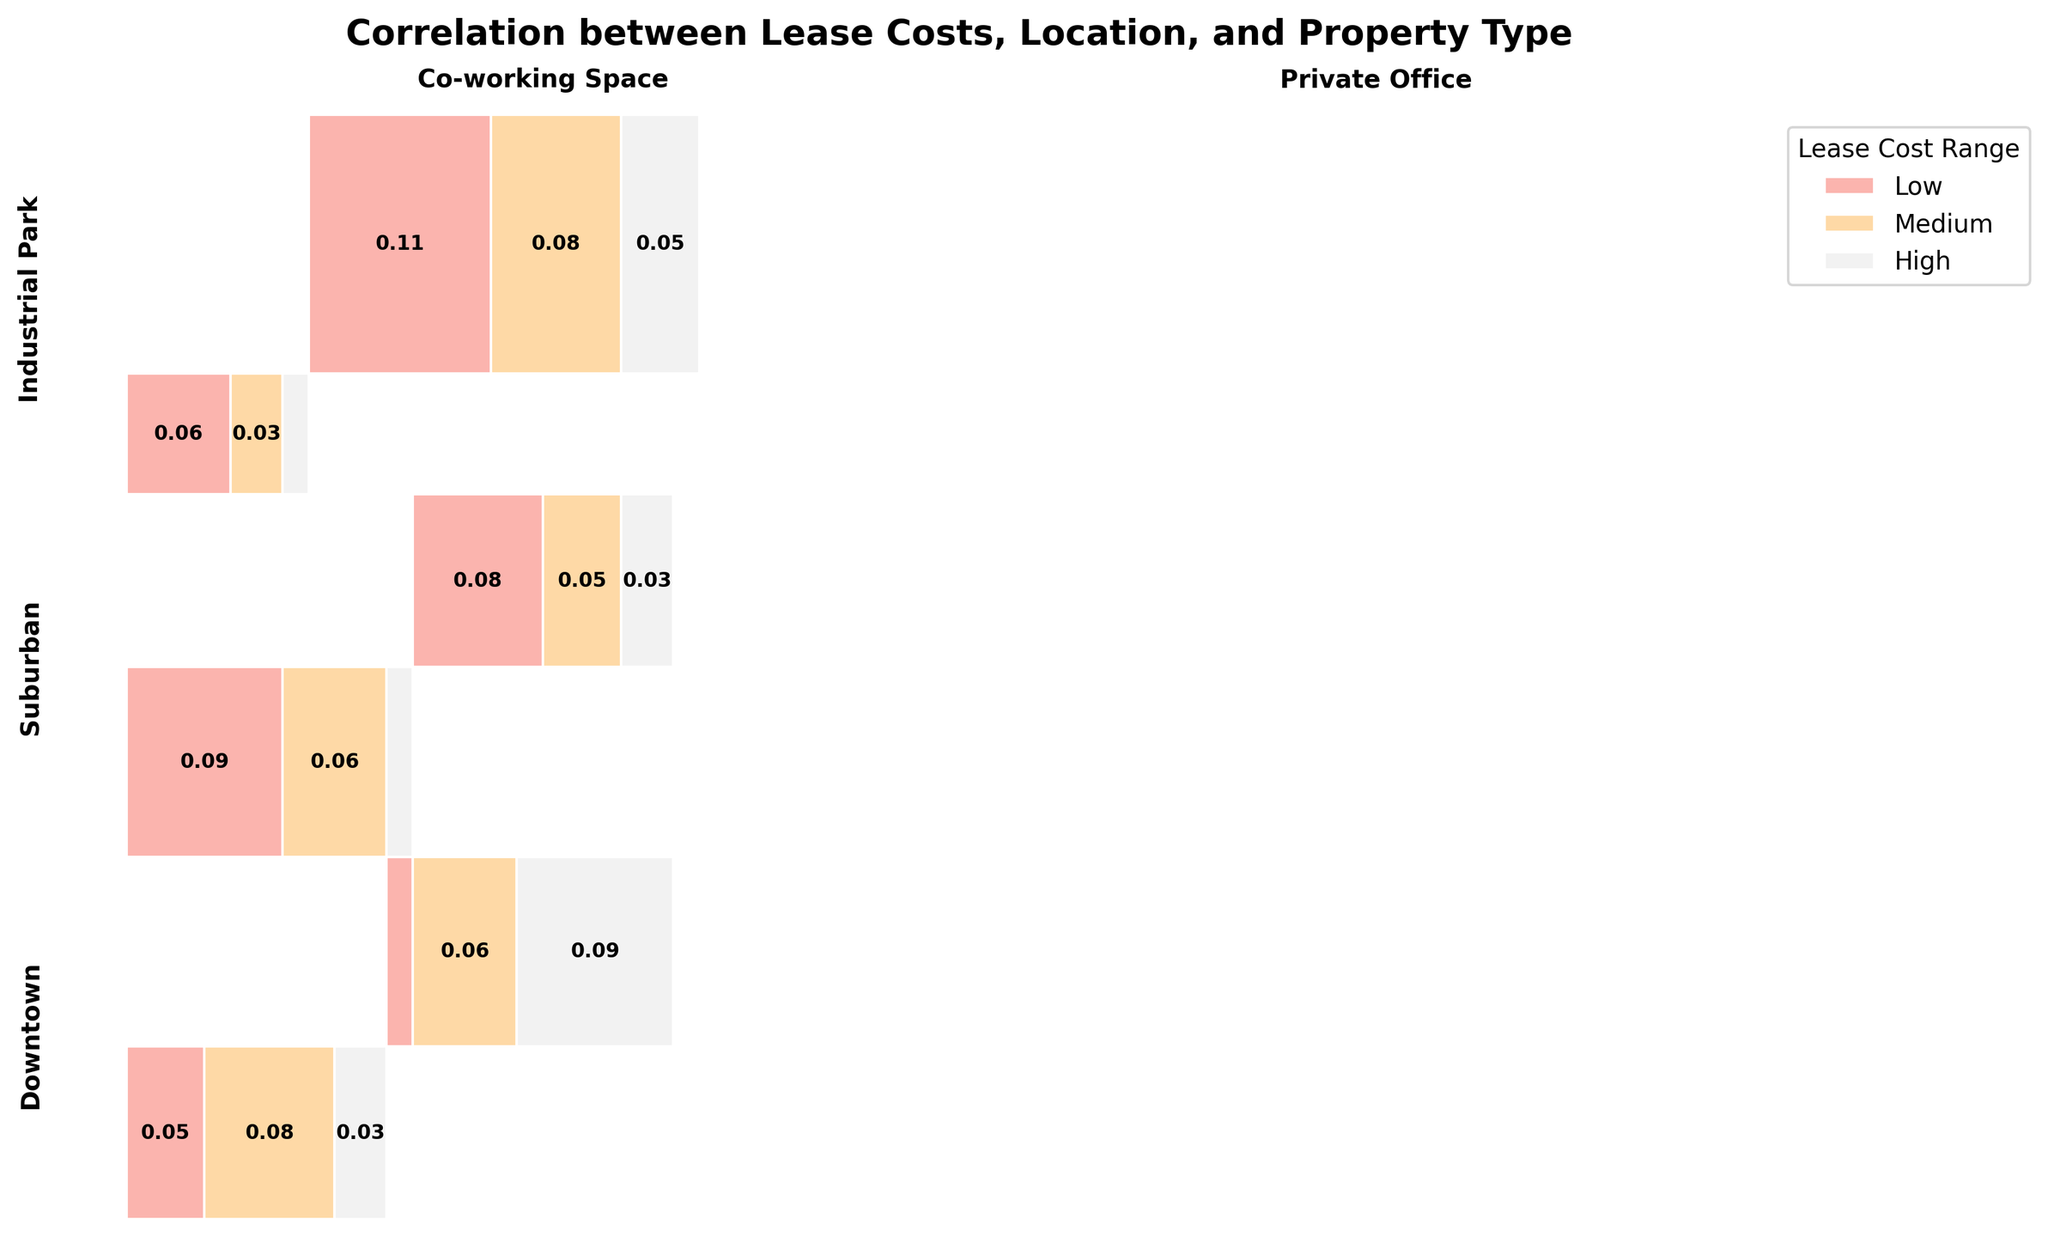What's the title of the mosaic plot? The title is usually located at the top of the plot. In this case, it reads "Correlation between Lease Costs, Location, and Property Type". The title helps in understanding the main focus of the plot.
Answer: Correlation between Lease Costs, Location, and Property Type What are the locations shown in the plot? The locations are typically indicated either in the legend or directly labeled on the plot. Here, the locations are "Downtown", "Suburban", and "Industrial Park". These locations are marked on the y-axis labels.
Answer: Downtown, Suburban, Industrial Park Which property type in the downtown area has the highest lease costs? Inspect the downtown section of the plot and identify which property type has the largest segment in the highest lease cost range (typically shown in a distinct color). In this case, it's the "Private Office". You can tell by comparing the sizes of the rectangles within the downtown area.
Answer: Private Office In which location is the proportion of low lease costs for co-working spaces the highest? To find this, compare the segments representing low lease costs (likely the first segments within each property type) across different locations for co-working spaces. Count the height of the low lease cost section within the co-working space blocks. The tallest bar segment indicates the highest proportion.
Answer: Suburban What is the total proportion of high lease costs in suburban co-working spaces? Find the segment representing high lease costs in the Suburban area within co-working spaces. By reading the proportion indicated in or around that segment, you'll see it's smaller compared to other segments. The calculation would be simply the proportion value written in the segment or inferred from visual comparison.
Answer: Small (specific numeric value like 5/100 or 5%) Compare the proportion of medium lease costs between suburban and industrial park private offices. Which one is larger? Look at the medium lease costs segments for private offices in both the Suburban and Industrial Park areas. Observe the size of these segments. The larger segment indicates a larger proportion, which in this case is Industrial Park.
Answer: Industrial Park What is the relationship shown between property types and lease cost ranges visually? The mosaic plot uses the size of each rectangle within property types across different locations to represent lease cost ranges. The arrangement and relative sizes of rectangles reflect the distribution of lease cost ranges within each property type and location.
Answer: Distribution of lease costs Would you say that high lease costs are more common in downtown areas compared to suburban areas for private offices? Why? By comparing the segment sizes of high lease costs for private offices in Downtown and Suburban areas, it's evident that the high-cost segment is significantly larger in Downtown. This suggests high lease costs are more common in that area.
Answer: Yes, because the high-cost segment is larger in Downtown In which property type and location is the presence of low lease costs the least? Check for the smallest segment representing low lease costs across all combinations of property types and locations. The lowest presence is in the "Private Office" in "Downtown", as visualized by the thin or absent low-cost segment.
Answer: Private Office in Downtown 